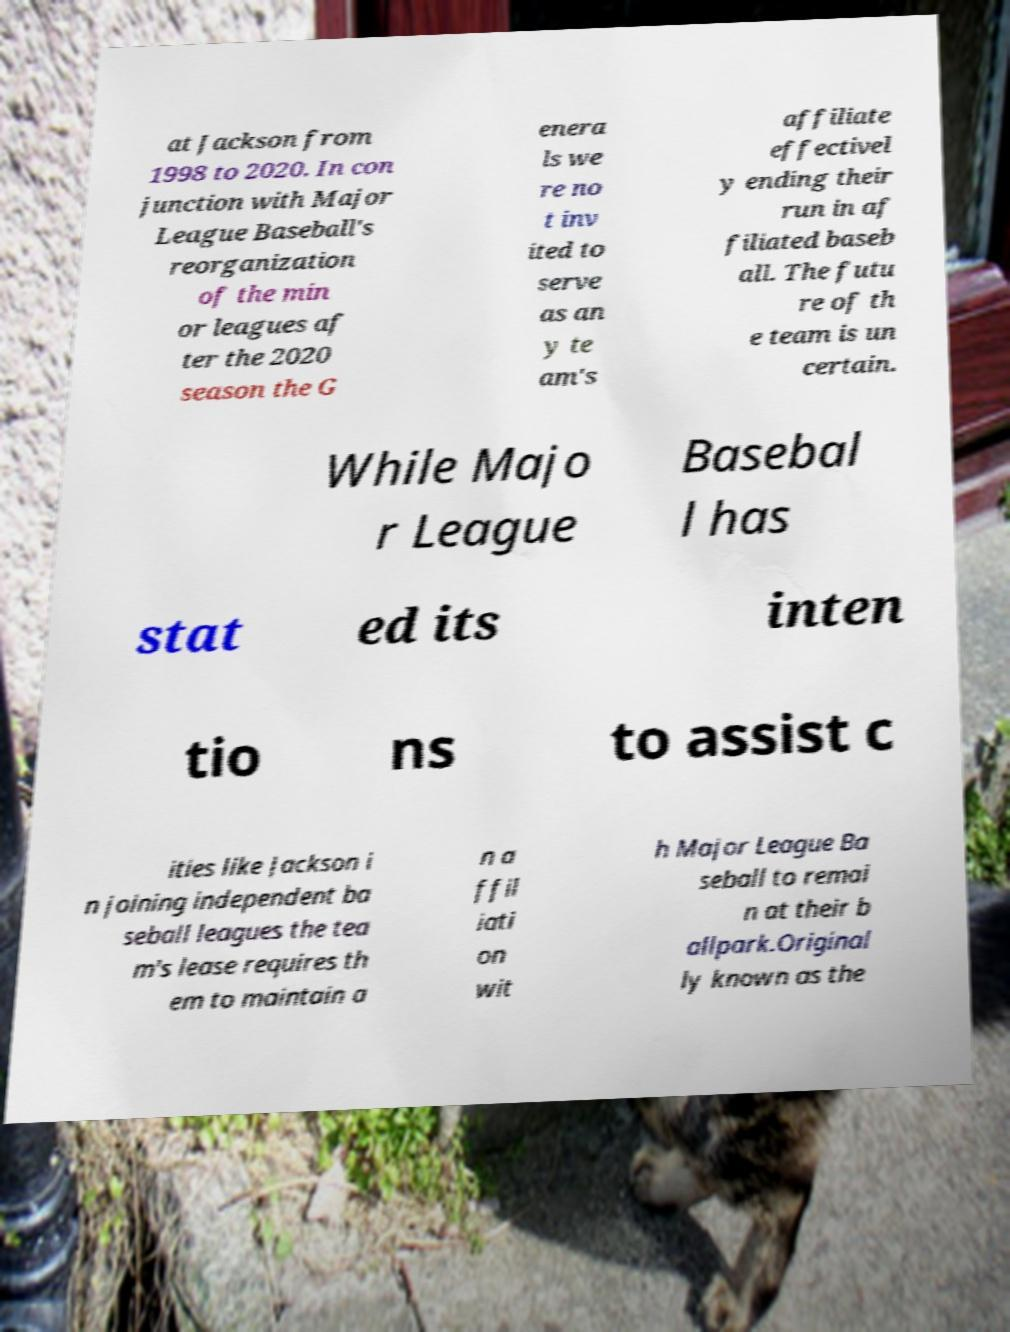There's text embedded in this image that I need extracted. Can you transcribe it verbatim? at Jackson from 1998 to 2020. In con junction with Major League Baseball's reorganization of the min or leagues af ter the 2020 season the G enera ls we re no t inv ited to serve as an y te am's affiliate effectivel y ending their run in af filiated baseb all. The futu re of th e team is un certain. While Majo r League Basebal l has stat ed its inten tio ns to assist c ities like Jackson i n joining independent ba seball leagues the tea m's lease requires th em to maintain a n a ffil iati on wit h Major League Ba seball to remai n at their b allpark.Original ly known as the 